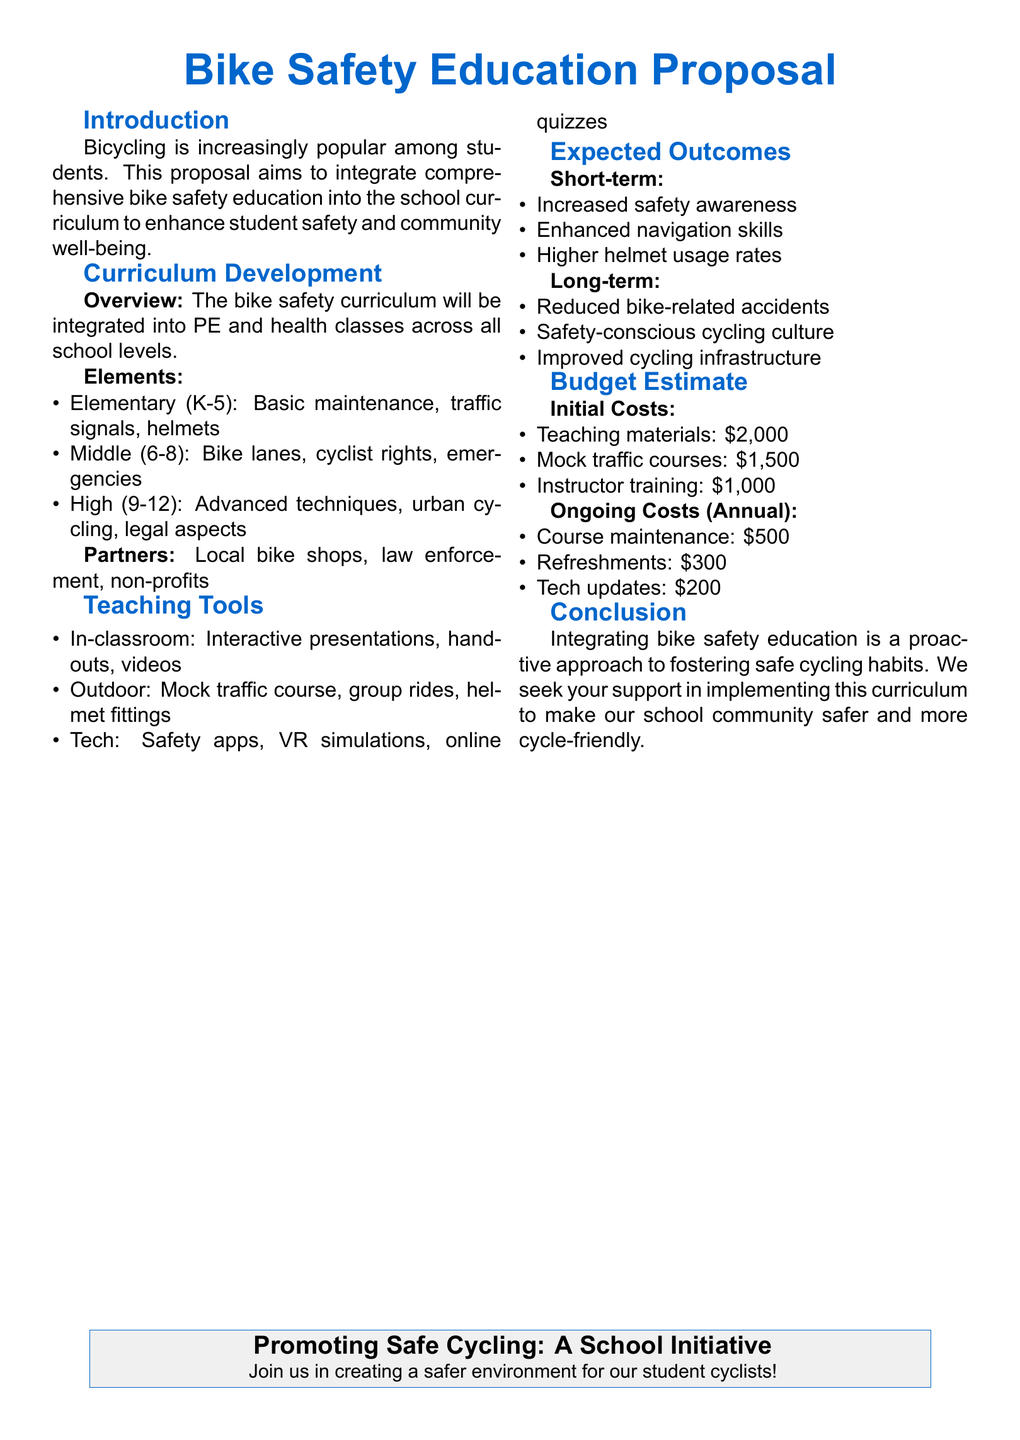What is the title of the proposal? The title of the proposal is stated at the top of the document.
Answer: Bike Safety Education Proposal What grade levels are included in the bike safety curriculum? The document outlines specific grade levels for the curriculum development.
Answer: K-12 What is one element taught to elementary students? The document lists specific elements for each grade level.
Answer: Basic maintenance Who are the proposed partners for the curriculum? Partners mentioned in the document include local organizations that can assist with the program.
Answer: Local bike shops, law enforcement, non-profits What is the estimated cost for teaching materials? The document includes an initial cost breakdown for implementing the curriculum.
Answer: $2,000 What is one expected long-term outcome of the program? The document outlines long-term benefits expected from integrating bike safety education.
Answer: Reduced bike-related accidents What type of teaching tools are planned for outdoor education? The document specifies different environments for education tools used in the program.
Answer: Mock traffic course How much is budgeted annually for course maintenance? The document includes both initial and ongoing costs for implementing the program.
Answer: $500 What is the objective of this proposal? The introduction outlines the main goal of the proposal for the school.
Answer: Enhance student safety and community well-being 